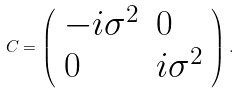<formula> <loc_0><loc_0><loc_500><loc_500>C = \left ( \begin{array} { l l } { { - i \sigma ^ { 2 } } } & { 0 } \\ { 0 } & { { i \sigma ^ { 2 } } } \end{array} \right ) .</formula> 